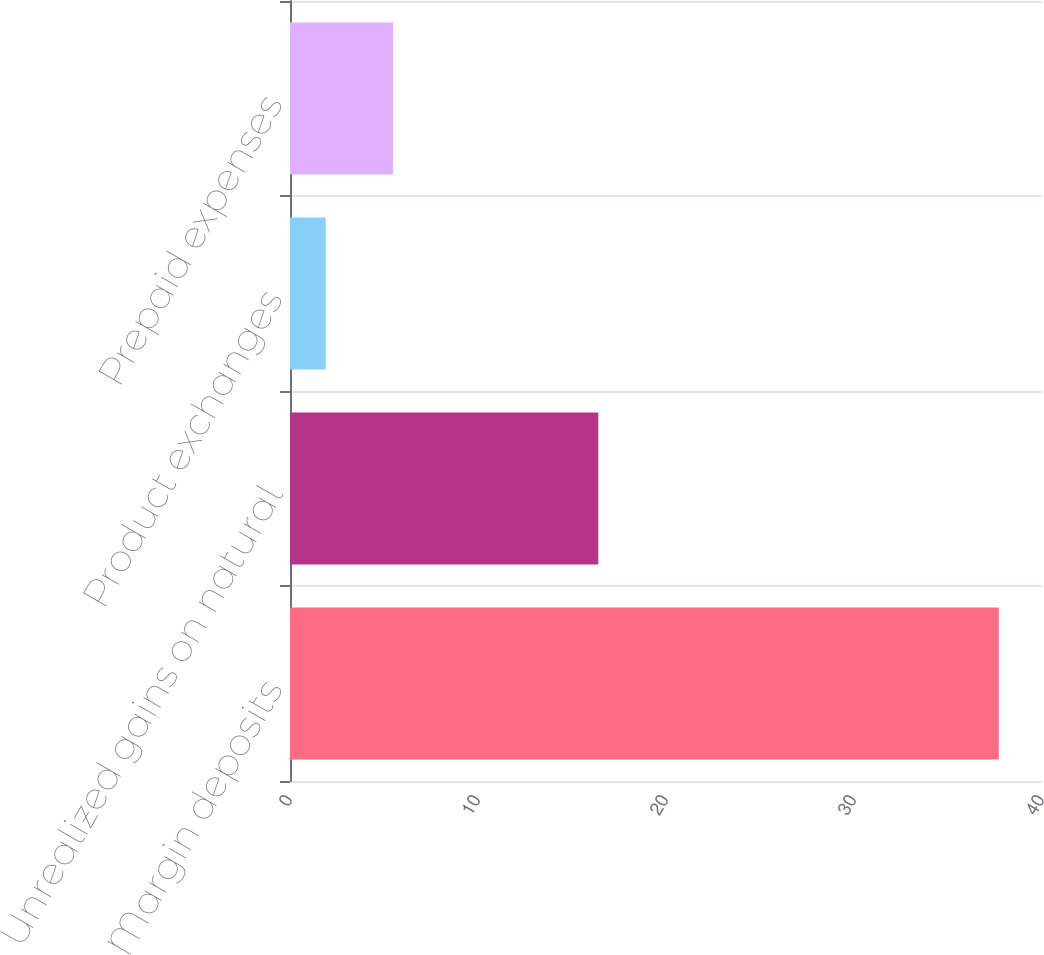Convert chart to OTSL. <chart><loc_0><loc_0><loc_500><loc_500><bar_chart><fcel>Margin deposits<fcel>Unrealized gains on natural<fcel>Product exchanges<fcel>Prepaid expenses<nl><fcel>37.7<fcel>16.4<fcel>1.9<fcel>5.48<nl></chart> 